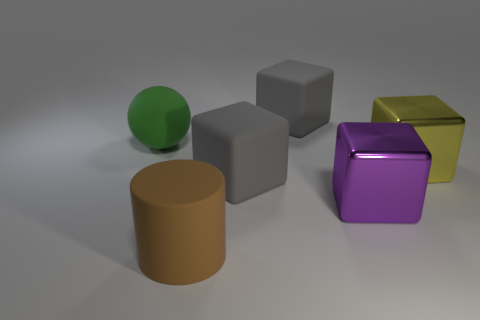What size is the gray block that is to the left of the large rubber object to the right of the large gray cube that is in front of the large yellow block?
Offer a terse response. Large. There is a big thing to the left of the big brown matte cylinder in front of the purple cube; what color is it?
Your response must be concise. Green. There is a big yellow thing that is the same shape as the large purple shiny object; what is it made of?
Your response must be concise. Metal. Are there any large gray matte objects left of the yellow thing?
Your answer should be compact. Yes. How many big cubes are there?
Your answer should be compact. 4. What number of gray matte blocks are in front of the gray object behind the matte ball?
Ensure brevity in your answer.  1. What number of other brown objects are the same shape as the brown rubber thing?
Offer a very short reply. 0. There is a large cube to the right of the big purple thing; what is its material?
Keep it short and to the point. Metal. There is a metal thing that is left of the yellow block; is it the same shape as the yellow metallic object?
Your answer should be very brief. Yes. Are there any other purple cubes of the same size as the purple block?
Keep it short and to the point. No. 